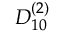Convert formula to latex. <formula><loc_0><loc_0><loc_500><loc_500>{ D } _ { 1 0 } ^ { ( 2 ) }</formula> 